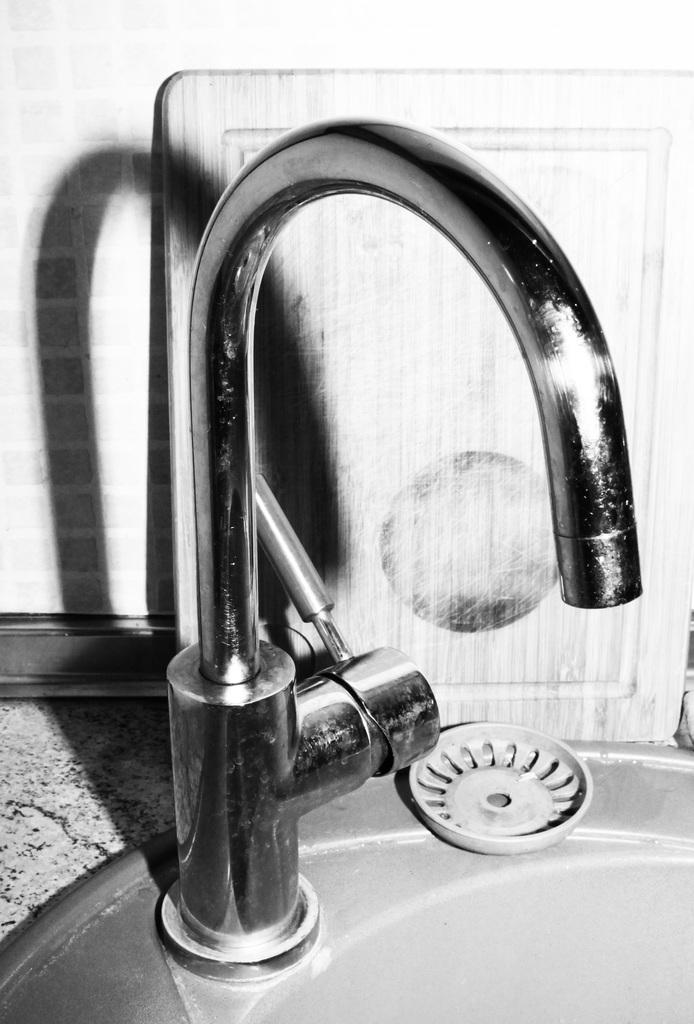In one or two sentences, can you explain what this image depicts? In this picture there is a tap in the center of the image. 